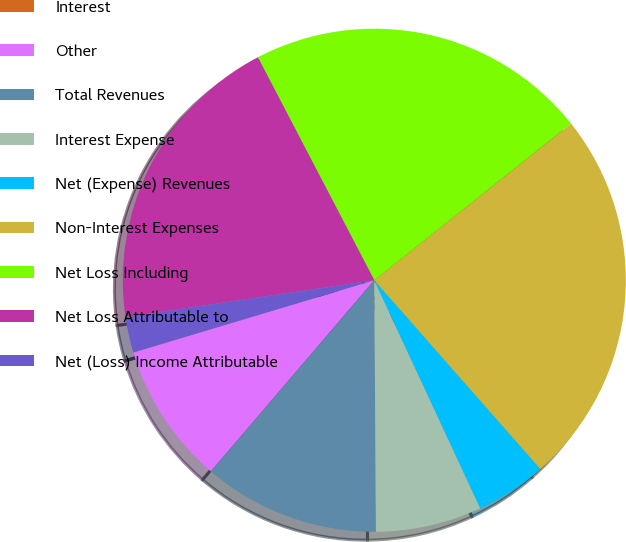Convert chart to OTSL. <chart><loc_0><loc_0><loc_500><loc_500><pie_chart><fcel>Interest<fcel>Other<fcel>Total Revenues<fcel>Interest Expense<fcel>Net (Expense) Revenues<fcel>Non-Interest Expenses<fcel>Net Loss Including<fcel>Net Loss Attributable to<fcel>Net (Loss) Income Attributable<nl><fcel>0.02%<fcel>9.09%<fcel>11.36%<fcel>6.82%<fcel>4.56%<fcel>24.22%<fcel>21.95%<fcel>19.68%<fcel>2.29%<nl></chart> 